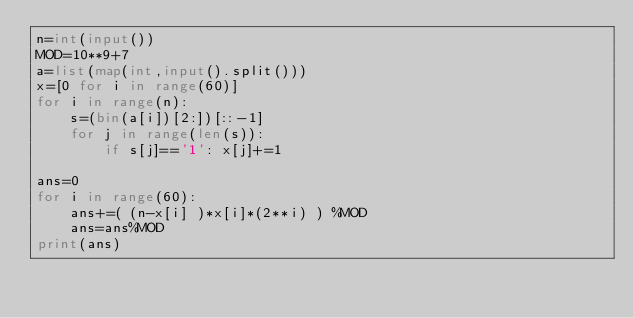<code> <loc_0><loc_0><loc_500><loc_500><_Python_>n=int(input())
MOD=10**9+7
a=list(map(int,input().split()))
x=[0 for i in range(60)]
for i in range(n):
    s=(bin(a[i])[2:])[::-1]
    for j in range(len(s)):
        if s[j]=='1': x[j]+=1

ans=0
for i in range(60):
    ans+=( (n-x[i] )*x[i]*(2**i) ) %MOD
    ans=ans%MOD
print(ans)</code> 